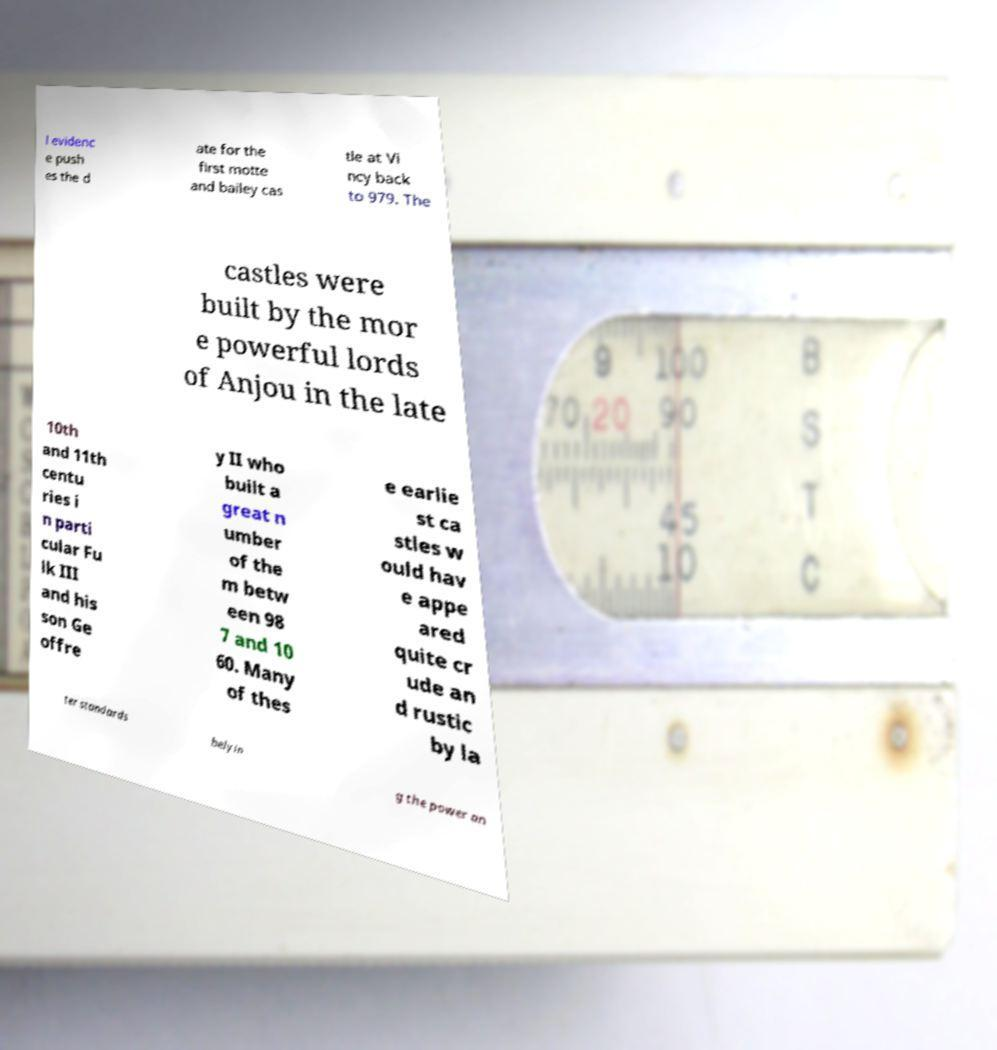Please identify and transcribe the text found in this image. l evidenc e push es the d ate for the first motte and bailey cas tle at Vi ncy back to 979. The castles were built by the mor e powerful lords of Anjou in the late 10th and 11th centu ries i n parti cular Fu lk III and his son Ge offre y II who built a great n umber of the m betw een 98 7 and 10 60. Many of thes e earlie st ca stles w ould hav e appe ared quite cr ude an d rustic by la ter standards belyin g the power an 